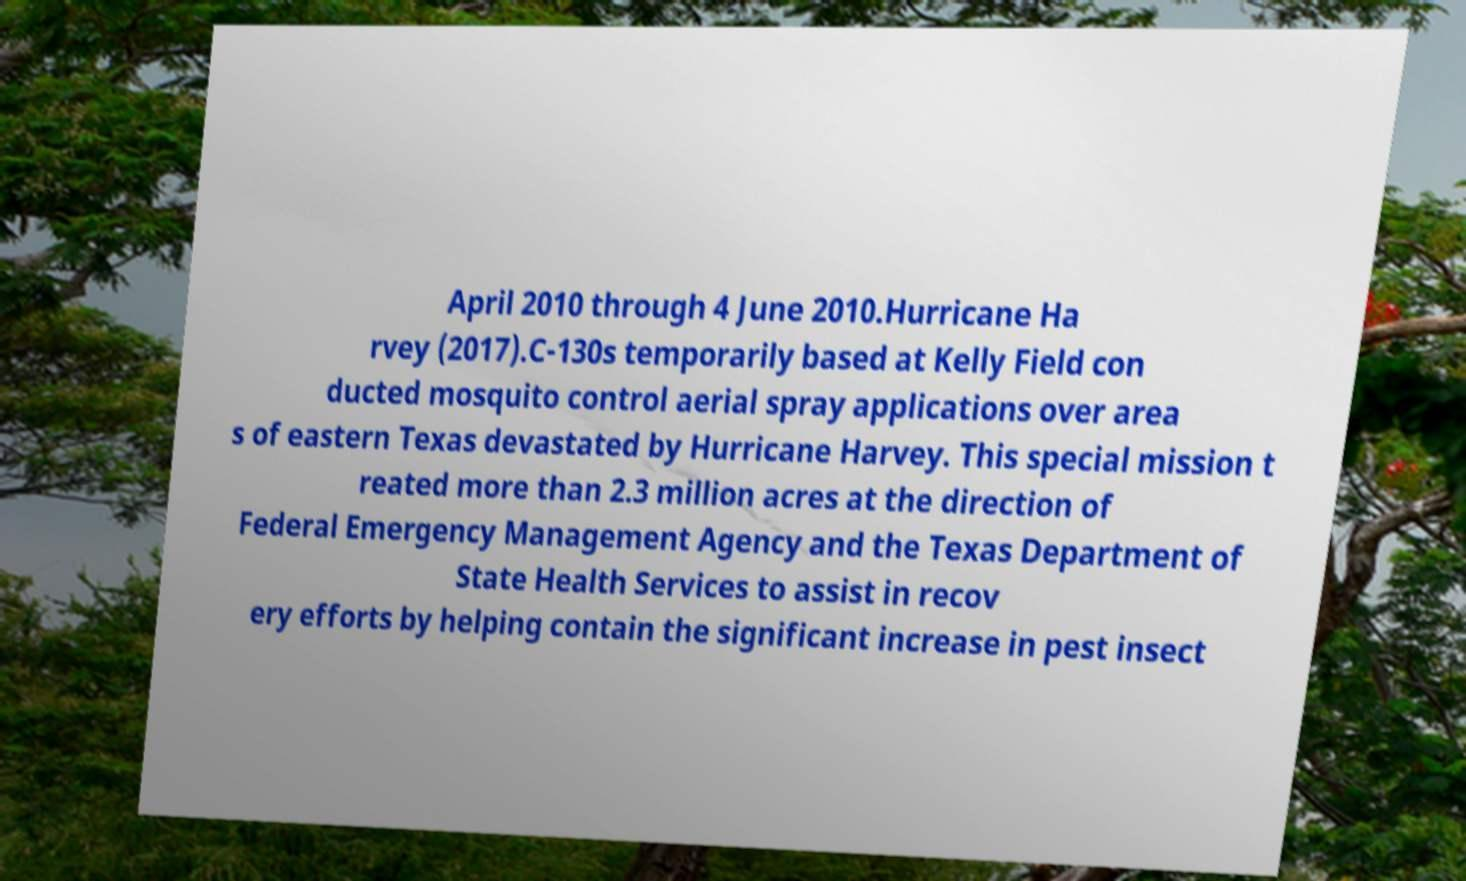For documentation purposes, I need the text within this image transcribed. Could you provide that? April 2010 through 4 June 2010.Hurricane Ha rvey (2017).C-130s temporarily based at Kelly Field con ducted mosquito control aerial spray applications over area s of eastern Texas devastated by Hurricane Harvey. This special mission t reated more than 2.3 million acres at the direction of Federal Emergency Management Agency and the Texas Department of State Health Services to assist in recov ery efforts by helping contain the significant increase in pest insect 